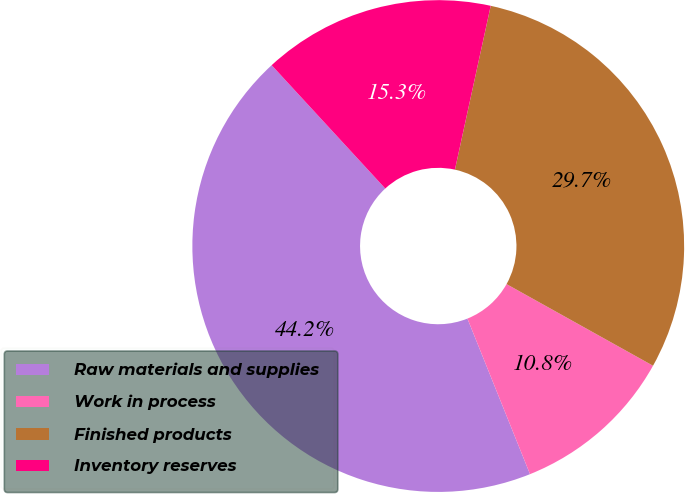Convert chart. <chart><loc_0><loc_0><loc_500><loc_500><pie_chart><fcel>Raw materials and supplies<fcel>Work in process<fcel>Finished products<fcel>Inventory reserves<nl><fcel>44.24%<fcel>10.82%<fcel>29.67%<fcel>15.27%<nl></chart> 